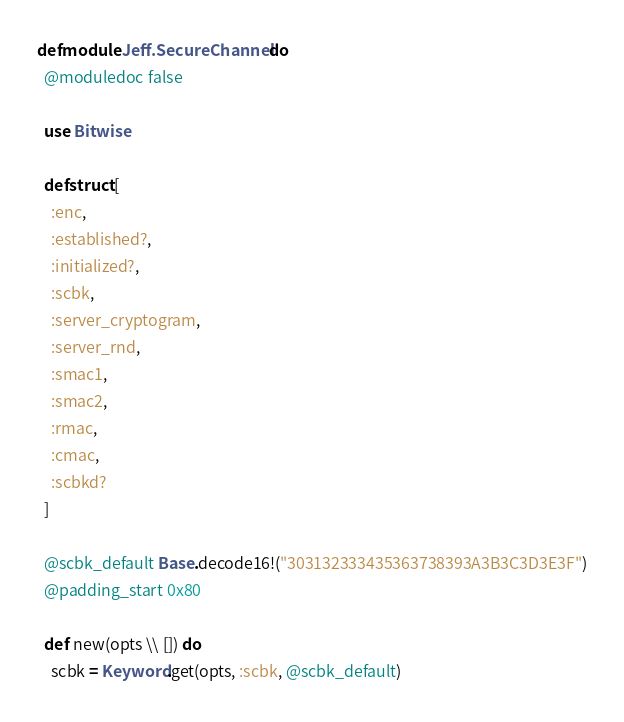<code> <loc_0><loc_0><loc_500><loc_500><_Elixir_>defmodule Jeff.SecureChannel do
  @moduledoc false

  use Bitwise

  defstruct [
    :enc,
    :established?,
    :initialized?,
    :scbk,
    :server_cryptogram,
    :server_rnd,
    :smac1,
    :smac2,
    :rmac,
    :cmac,
    :scbkd?
  ]

  @scbk_default Base.decode16!("303132333435363738393A3B3C3D3E3F")
  @padding_start 0x80

  def new(opts \\ []) do
    scbk = Keyword.get(opts, :scbk, @scbk_default)</code> 